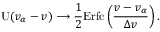Convert formula to latex. <formula><loc_0><loc_0><loc_500><loc_500>U ( v _ { \alpha } - v ) \longrightarrow \frac { 1 } { 2 } E r f c \left ( \frac { v - v _ { \alpha } } { \Delta v } \right ) .</formula> 